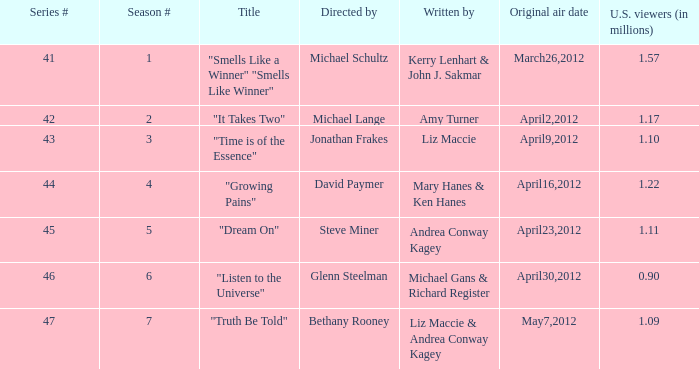When did the first airing of the episode named "truth be told" occur? May7,2012. 